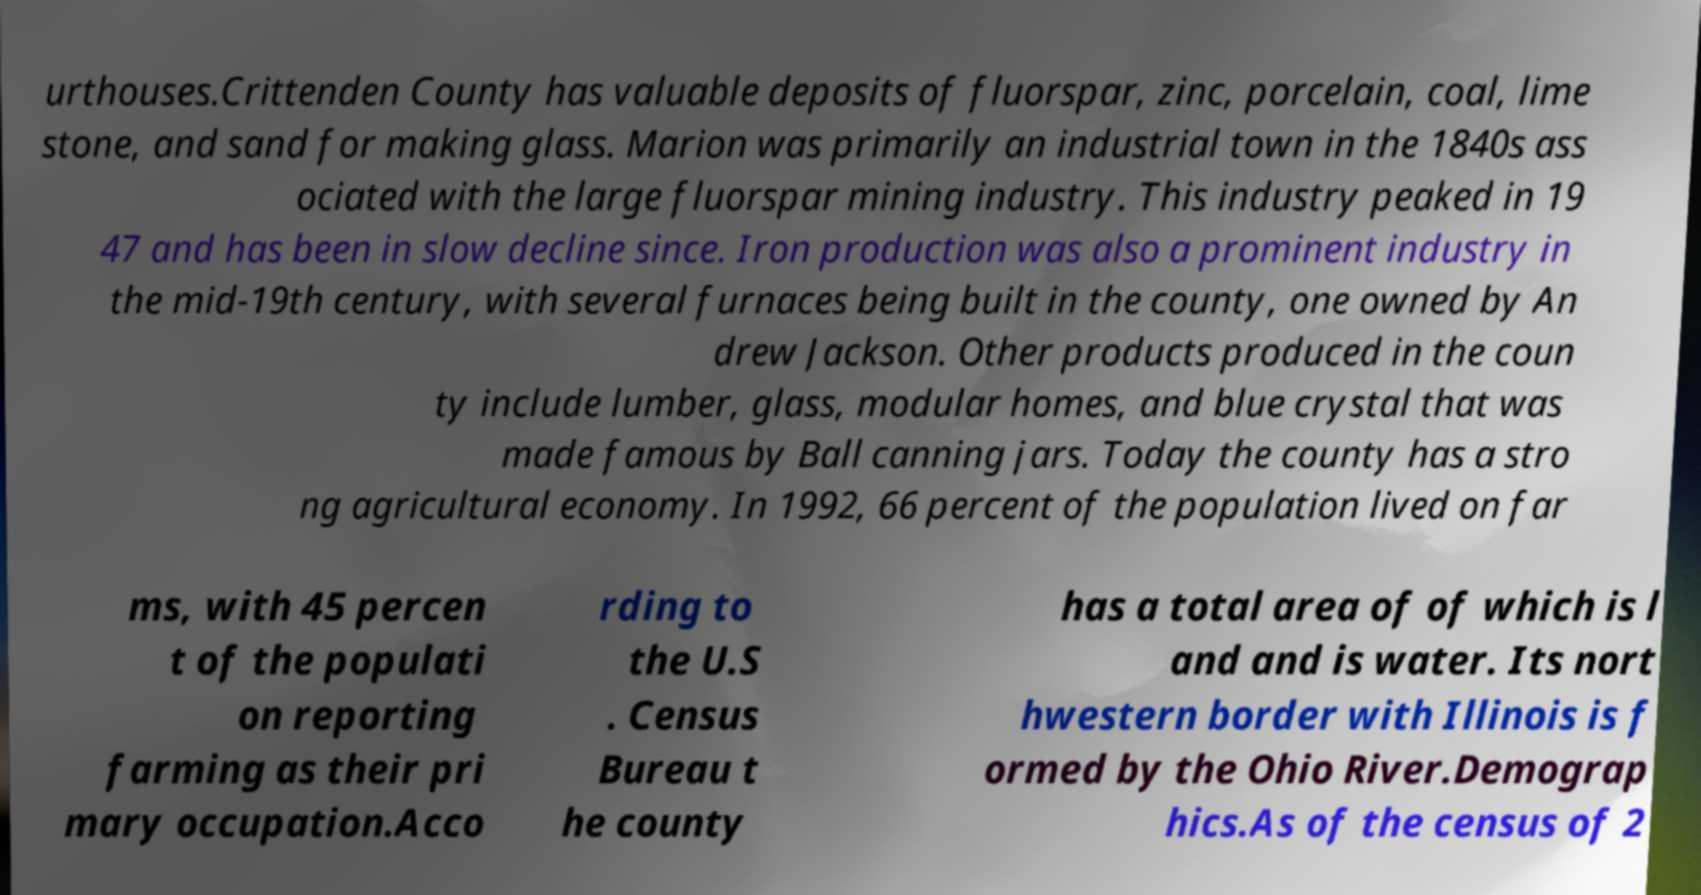For documentation purposes, I need the text within this image transcribed. Could you provide that? urthouses.Crittenden County has valuable deposits of fluorspar, zinc, porcelain, coal, lime stone, and sand for making glass. Marion was primarily an industrial town in the 1840s ass ociated with the large fluorspar mining industry. This industry peaked in 19 47 and has been in slow decline since. Iron production was also a prominent industry in the mid-19th century, with several furnaces being built in the county, one owned by An drew Jackson. Other products produced in the coun ty include lumber, glass, modular homes, and blue crystal that was made famous by Ball canning jars. Today the county has a stro ng agricultural economy. In 1992, 66 percent of the population lived on far ms, with 45 percen t of the populati on reporting farming as their pri mary occupation.Acco rding to the U.S . Census Bureau t he county has a total area of of which is l and and is water. Its nort hwestern border with Illinois is f ormed by the Ohio River.Demograp hics.As of the census of 2 